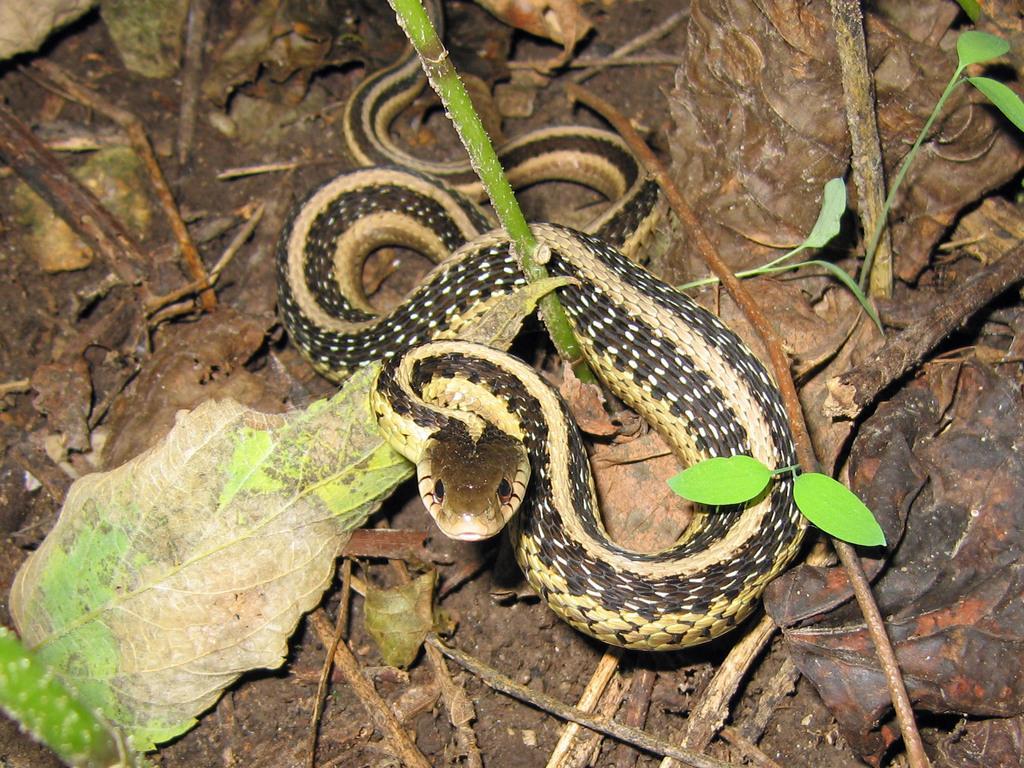How would you summarize this image in a sentence or two? In this picture I can see a snake, there are leaves and stems. 